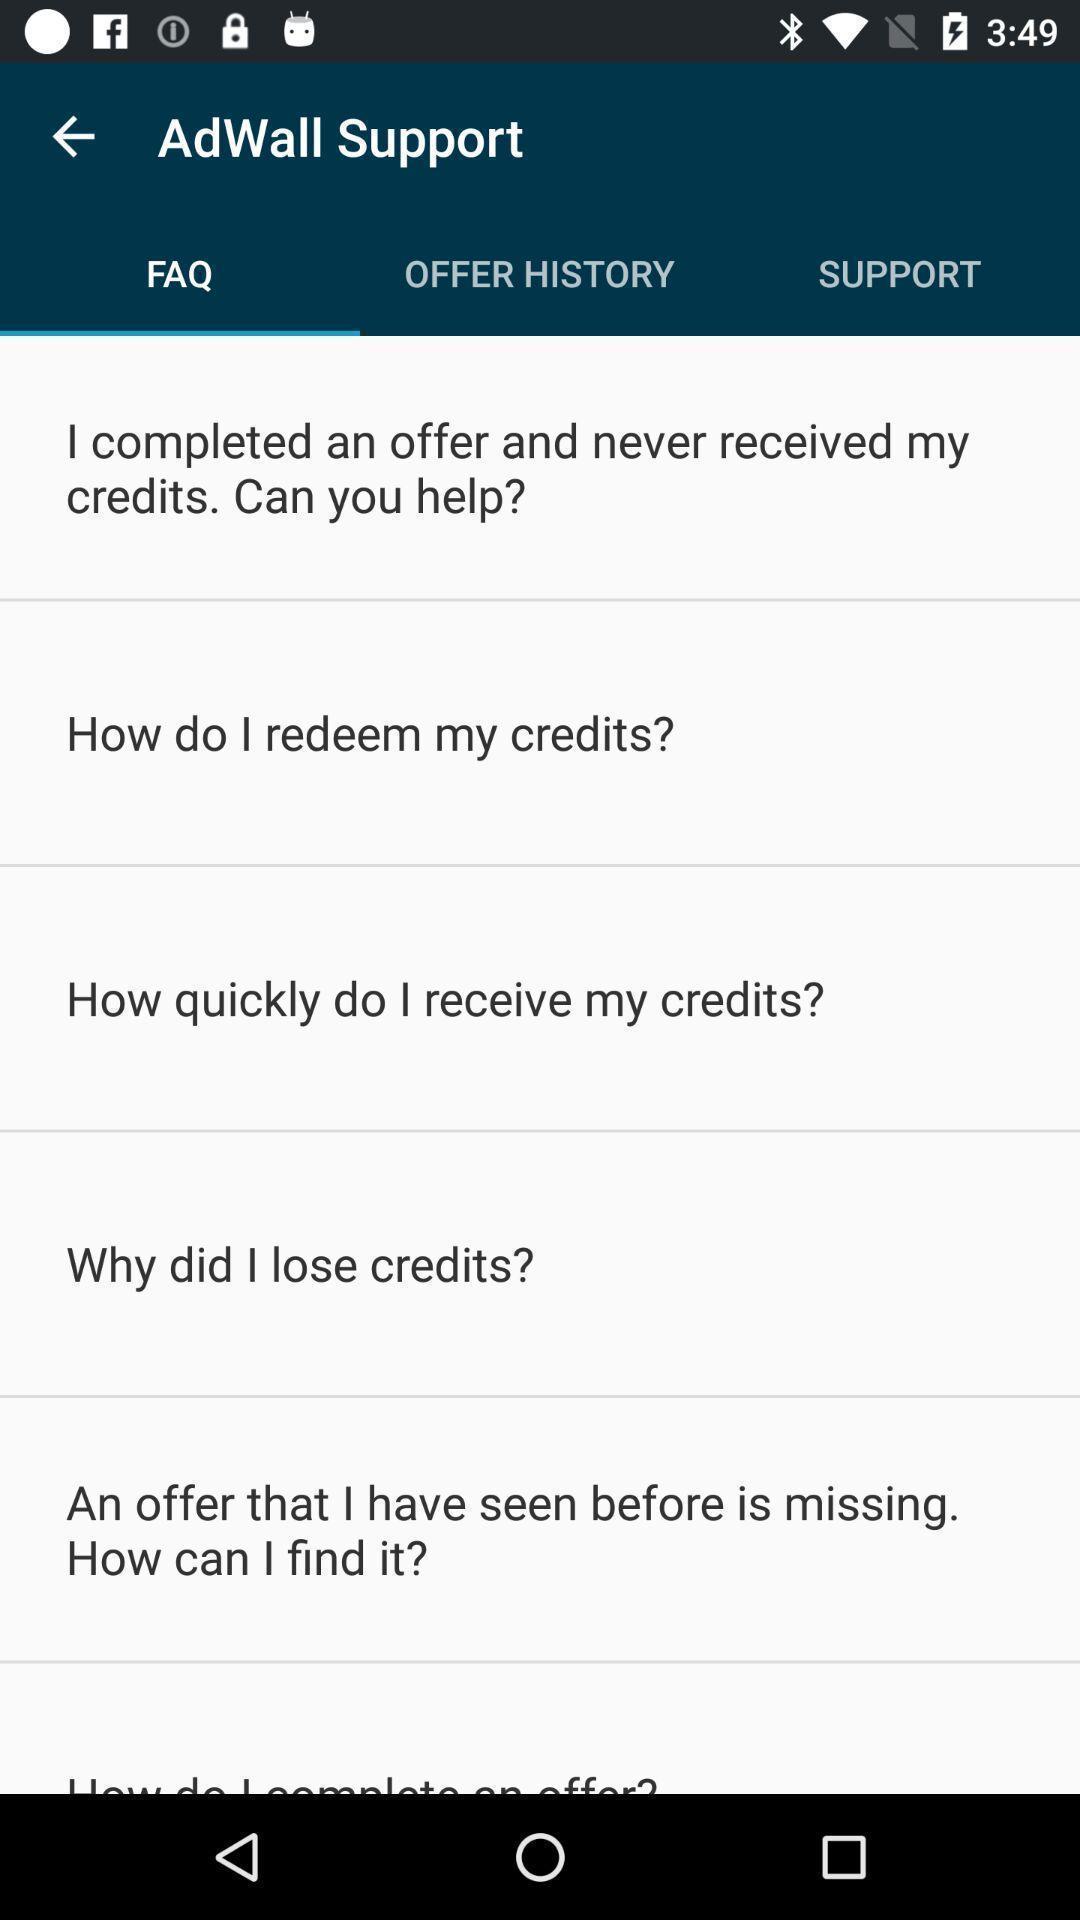Tell me about the visual elements in this screen capture. Page displays the faq of the social app. 